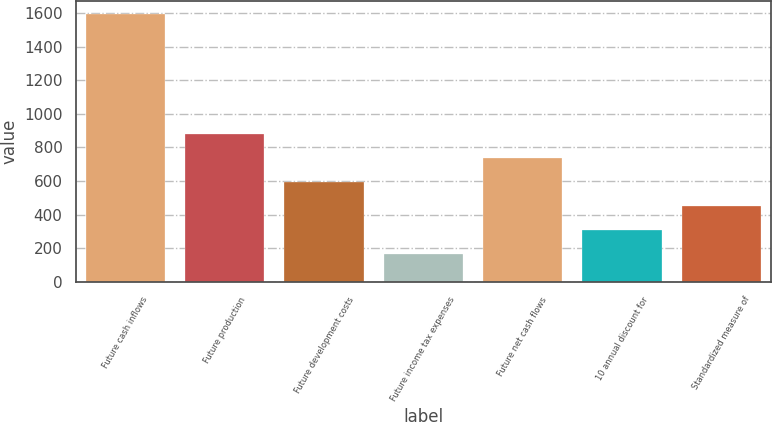Convert chart to OTSL. <chart><loc_0><loc_0><loc_500><loc_500><bar_chart><fcel>Future cash inflows<fcel>Future production<fcel>Future development costs<fcel>Future income tax expenses<fcel>Future net cash flows<fcel>10 annual discount for<fcel>Standardized measure of<nl><fcel>1593<fcel>878<fcel>592<fcel>163<fcel>735<fcel>306<fcel>449<nl></chart> 